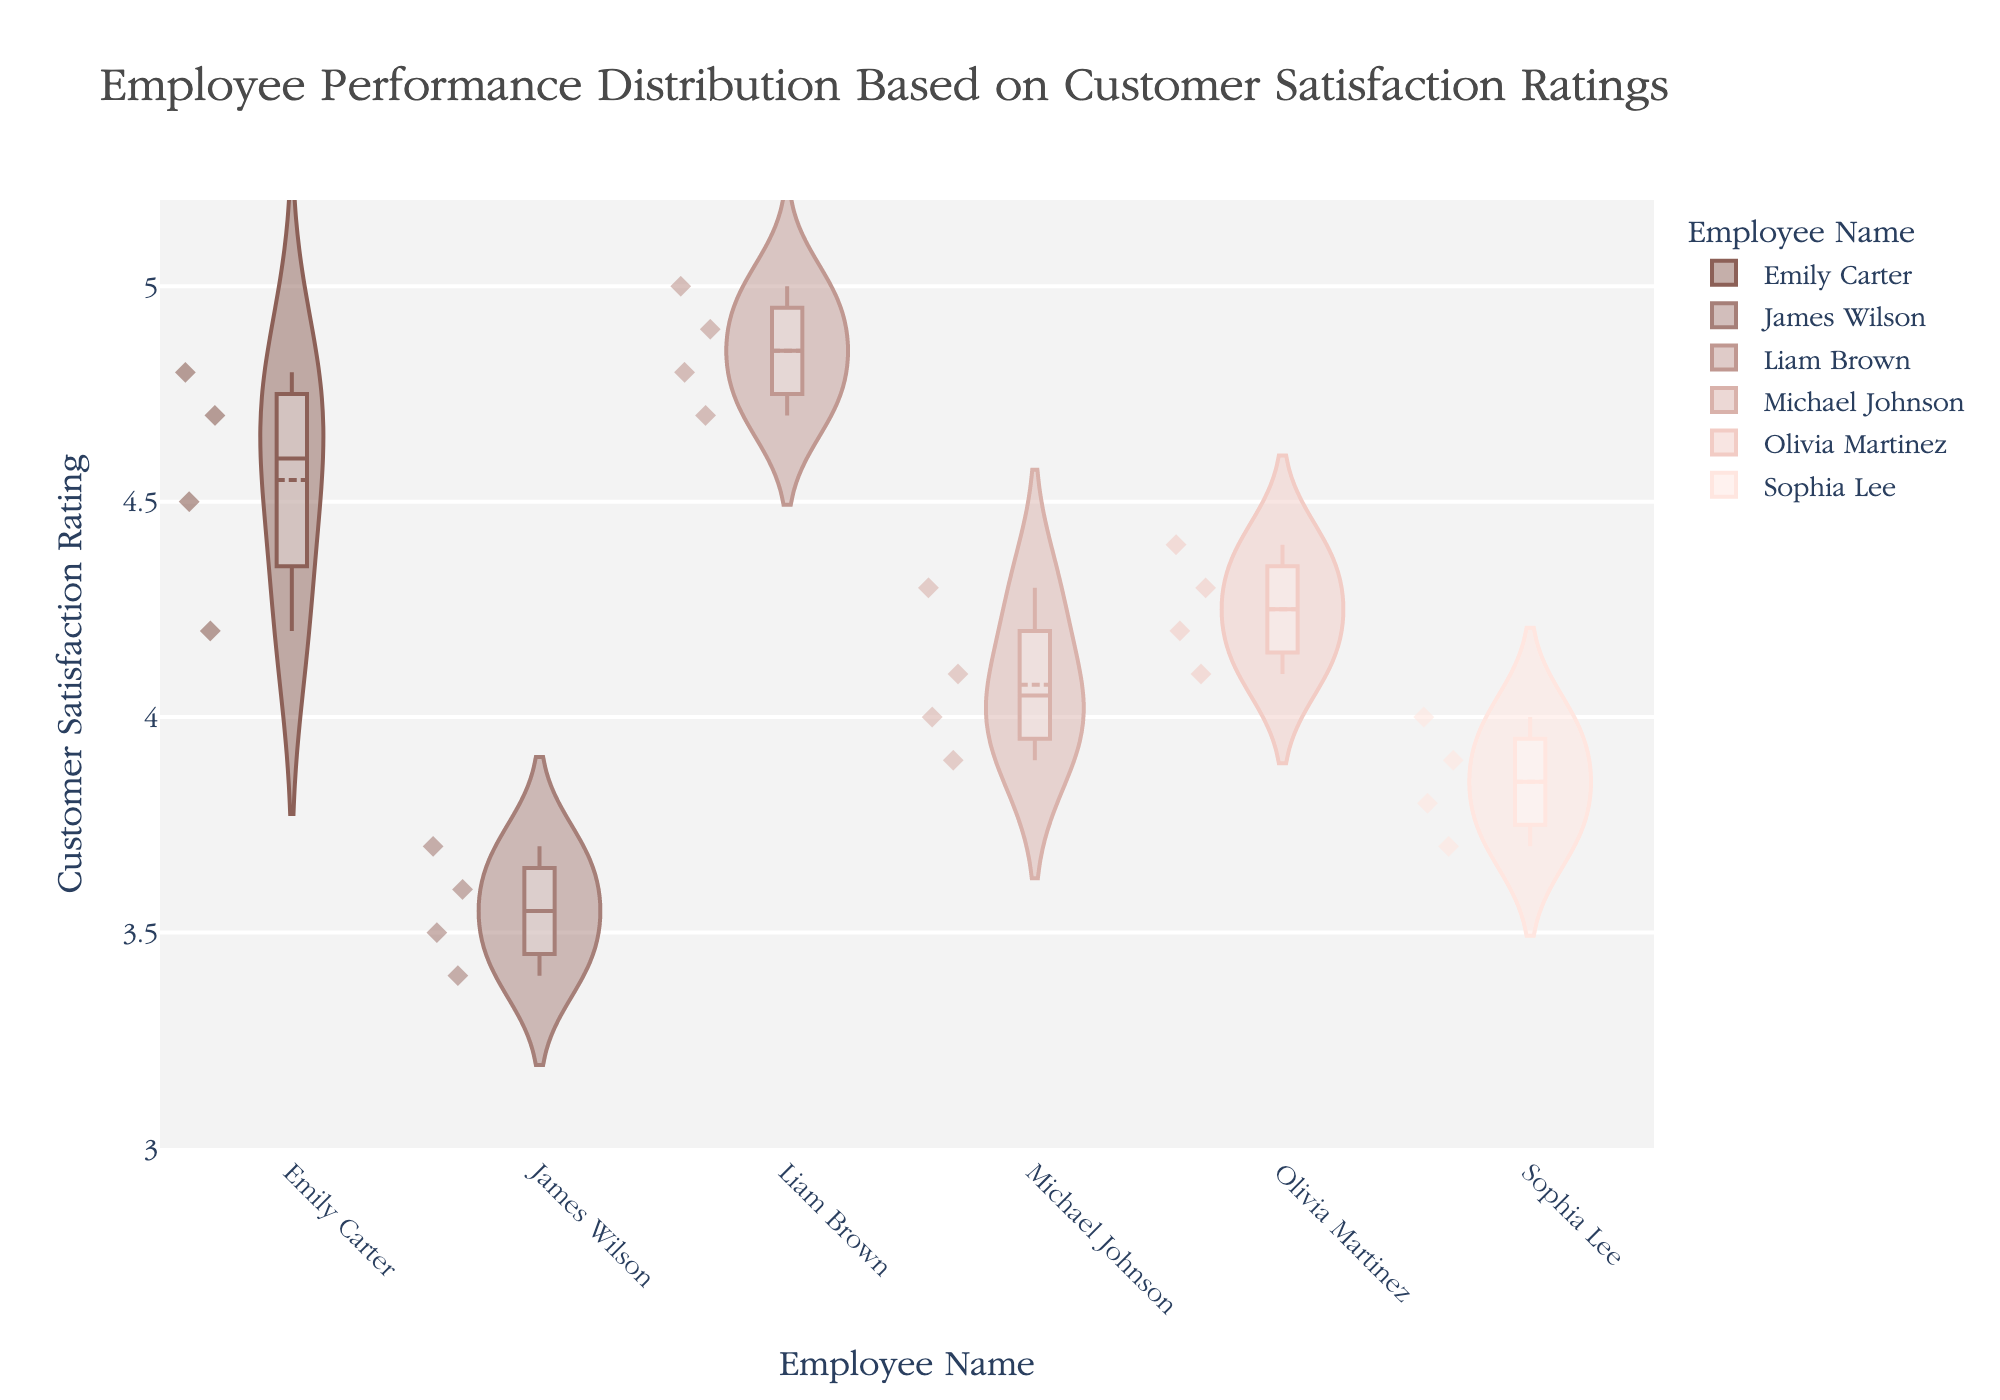What is the title of the violin chart? The title of the chart is usually displayed at the top of the plot. In this case, it states clearly what the chart is about.
Answer: Employee Performance Distribution Based on Customer Satisfaction Ratings How many employees are represented in the violin plot? Each unique color-coded section on the x-axis represents an individual employee's name. Counting these will give the total number of employees.
Answer: 6 Which employee has the widest distribution of customer satisfaction ratings? The widest distribution will be the employee whose violin plot spans the largest range on the y-axis.
Answer: James Wilson What is the highest customer satisfaction rating achieved, and by which employee? The highest rating can be found at the topmost point of all violin plots. By checking the corresponding employee name, we get the answer.
Answer: 5.0 by Liam Brown Which employee has the median customer satisfaction rating closest to 4.0? The median rating is typically represented by a line within the box plot inside each violin. Checking each employee's median will show which is closest to 4.0.
Answer: Sophia Lee How does Emily Carter's performance distribution compare to Michael Johnson's? Compare the width, range, and box plot features of Emily Carter's and Michael Johnson's violins. This will show their rating spread and focus.
Answer: Emily Carter's ratings are slightly higher and more spread out than Michael Johnson’s What is the average customer satisfaction rating for Olivia Martinez? Locate the box plot within Olivia Martinez's violin, find the midpoint or the median, and then estimate the average as being slightly around this value if the distribution is symmetrical.
Answer: Around 4.25 Which employee has the most consistent (narrowest) customer satisfaction ratings? Consistency in this context refers to a narrower, tighter distribution around the center of the violin plot.
Answer: Liam Brown What can you infer about James Wilson's range of customer satisfaction ratings compared to the others? James Wilson’s violin plot shows a wider range, indicating his ratings are more spread out. Compare visually with other employees' violins to conclude.
Answer: Broader and more varied Is there any overlap in customer satisfaction ratings between Michael Johnson and Sophia Lee? Look at the y-axis range of both Michael Johnson and Sophia Lee. If there is any vertical region where both violins intersect, there is an overlap.
Answer: Yes, between 3.7 and 4.1 